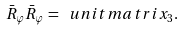Convert formula to latex. <formula><loc_0><loc_0><loc_500><loc_500>\bar { R } _ { \varphi } \bar { R } _ { \varphi } = \ u n i t m a t r i x _ { 3 } .</formula> 